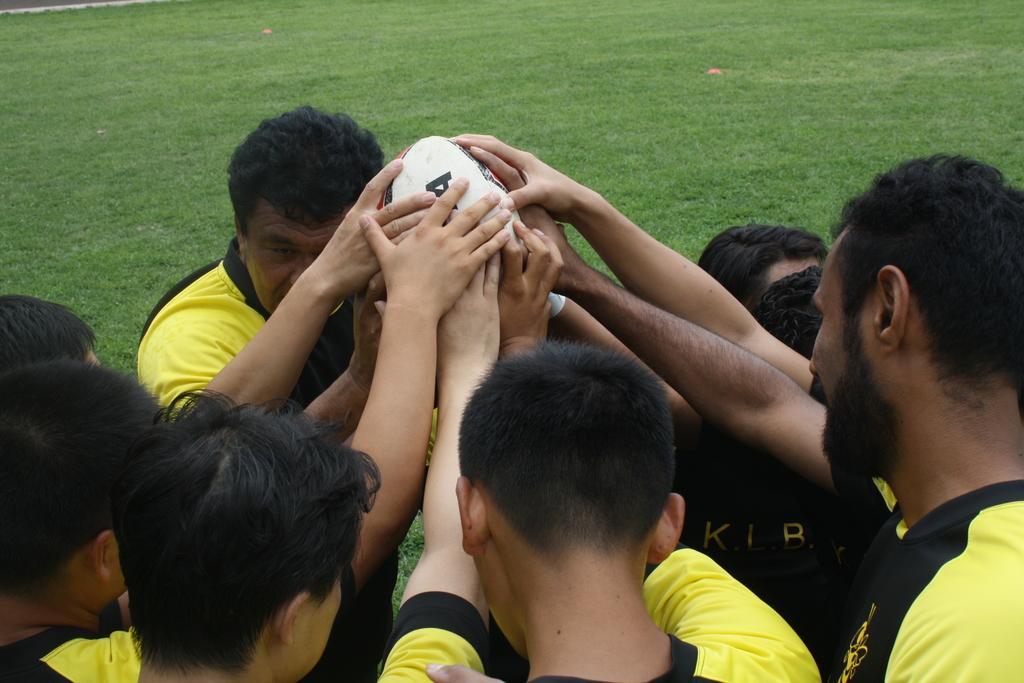Please provide a concise description of this image. In the picture we can see some players wearing a yellow T-shirts and holding a ball which is white in color and in the background we can see a grass surface. 